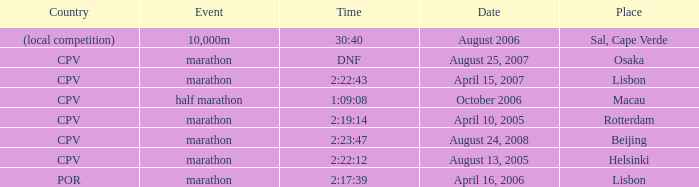What is the nation of the half marathon event? CPV. 